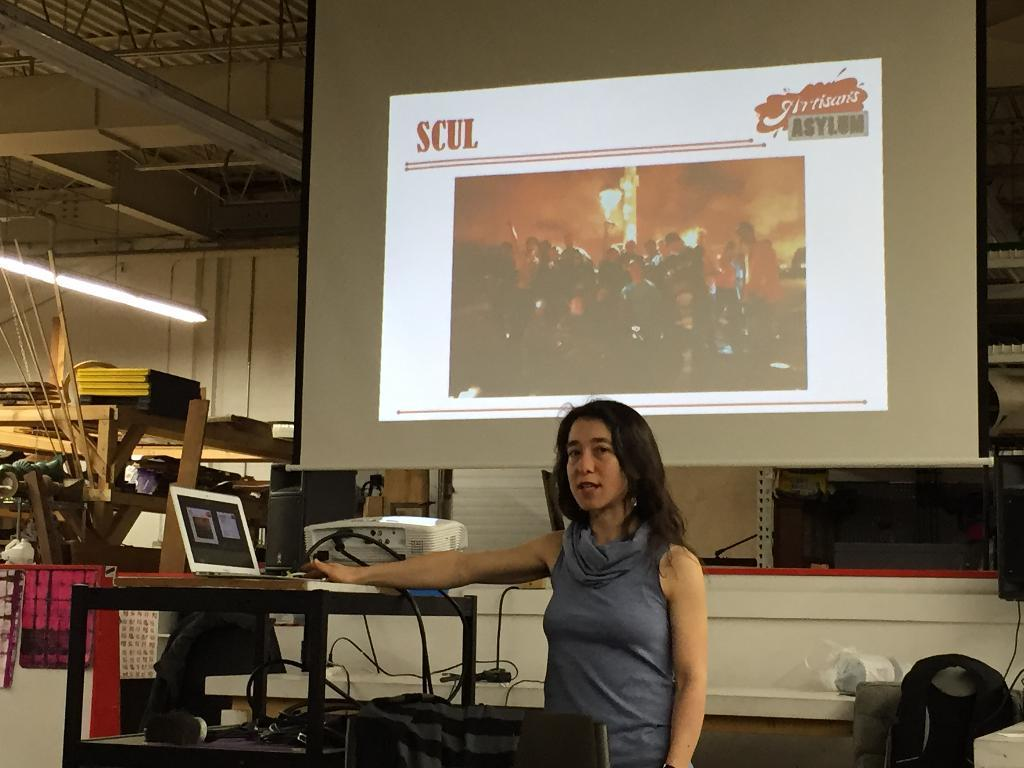<image>
Present a compact description of the photo's key features. A woman at her desk with a projected image on the wall behind her with the words SCUL and ASYLUM 